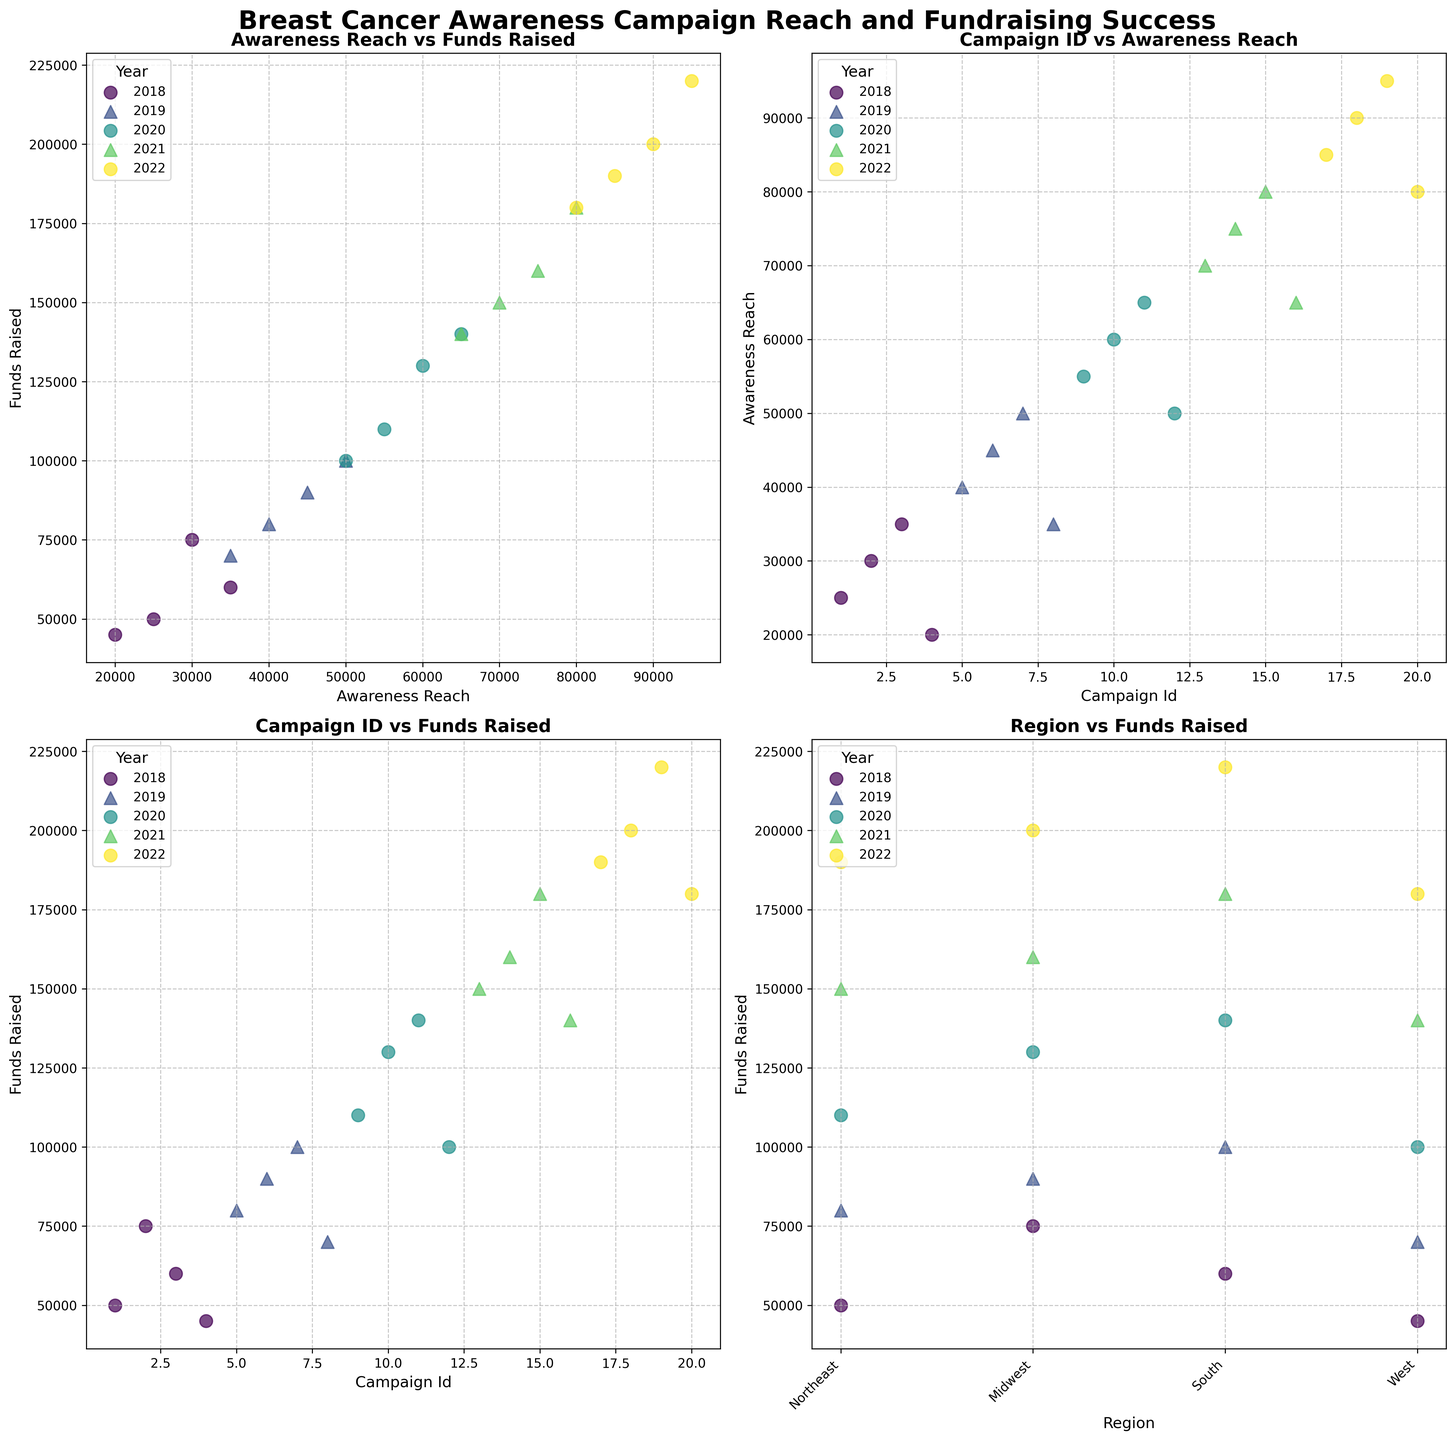What trend can you observe in the 'Awareness Reach vs Funds Raised' subplot? The dots in the 'Awareness Reach vs Funds Raised' subplot seem to have a positive correlation, meaning that as awareness reach increases, the funds raised also tend to increase. This can be seen as all points move towards the upper right corner of the plot.
Answer: Positive correlation Which year has the highest campaign reach in the 'Campaign ID vs Awareness Reach' subplot? To find this, we need to locate the highest point along the y-axis in the 'Campaign ID vs Awareness Reach' subplot. For Campaign ID 19 in 2022, the awareness reach is 95,000 which is the highest value on this plot.
Answer: 2022 Compare the funds raised by campaign IDs in the Midwest region for the years 2018 and 2022 in the 'Region vs Funds Raised' subplot. In the 'Region vs Funds Raised' subplot, for the Midwest region, locate 2018 and 2022 (can be done through color coding and marker shapes). For 2018, the funds raised are approximately 75,000, while for 2022, they are around 200,000. Thus, funds raised have increased substantially from 2018 to 2022.
Answer: 75,000 vs 200,000 What region had the highest funds raised in 2021 according to the 'Region vs Funds Raised' subplot? In the 'Region vs Funds Raised' subplot, for 2021, identify the data point that is the highest on the y-axis (can be done through color coding and marker shapes). The South region raises the most funds with the funds approaching 180,000.
Answer: South How do the campaigns in 2019 differ in terms of funds raised compared to those in 2020 according to the 'Campaign ID vs Funds Raised' subplot? Compare the scatter points for campaign IDs in 2019 and 2020 in the 'Campaign ID vs Funds Raised' subplot. In 2019, the funds raised range around 90,000, 100,000, and 110,000, while in 2020 for similar IDs (10, 11, 12), the funds raised move towards 130,000, 140,000, and 100,000. Thus, campaigns in 2020 tend to have higher funds raised than in 2019.
Answer: Higher in 2020 